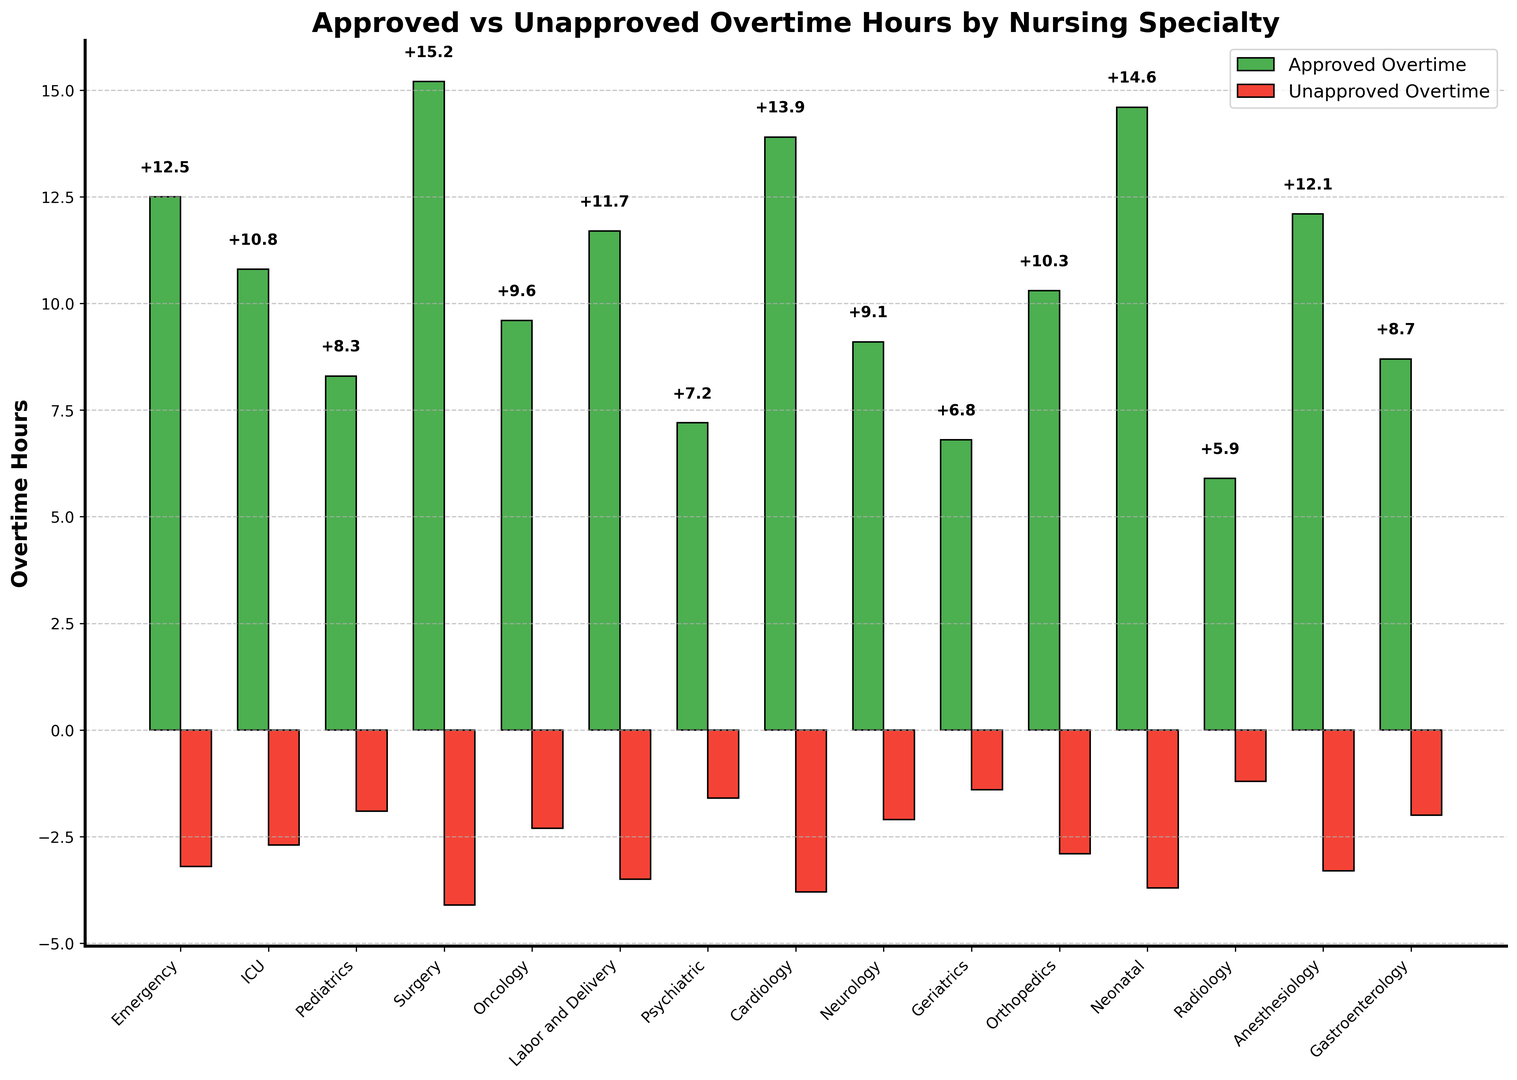Which nursing specialty has the highest approved overtime? The bar labeled "Surgery" reaches the highest point among the green bars, indicating it has the maximum approved overtime hours.
Answer: Surgery What is the difference between approved and unapproved overtime hours for Cardiology? Cardiology has 13.9 approved overtime hours and -3.8 unapproved overtime hours. The difference is 13.9 - (-3.8) = 17.7.
Answer: 17.7 Which specialty has the smallest amount of total overtime, whether approved or unapproved? Radiology has 5.9 approved overtime hours and -1.2 unapproved overtime hours. The sum is 5.9 + (-1.2) = 4.7, which is the smallest total value among all specialties.
Answer: Radiology How many specialties have unapproved overtime more negative than -3? By visually inspecting the bars on the right (red bars): Emergency, Surgery, Labor and Delivery, Cardiology, Neonatal, and Anesthesiology all have unapproved overtime values more negative than -3. This sums up to 6 specialties.
Answer: 6 Which specialties have more than 12 approved overtime hours? The green bars indicating approved overtime hours above 12 are seen in Emergency, Surgery, Cardiology, Neonatal, and Anesthesiology.
Answer: Emergency, Surgery, Cardiology, Neonatal, Anesthesiology What is the average amount of approved overtime for the three specialties with the most unapproved overtime? The specialties with the most unapproved overtime (most negative) are Surgery (-4.1), Neonatal (-3.7), and Cardiology (-3.8). Their approved overtime values are 15.2, 14.6, and 13.9. The sum of these values is 15.2 + 14.6 + 13.9 = 43.7. Dividing by 3, the average is 43.7 / 3 = 14.57.
Answer: 14.57 What is the total unapproved overtime for the specialties in critical care (Emergency, ICU)? Emergency has -3.2 unapproved overtime hours and ICU has -2.7 unapproved overtime hours. The total is -3.2 + (-2.7) = -5.9.
Answer: -5.9 Which specialty has the least approved overtime? The bar for Radiology in the green section is the shortest, indicating it has the least approved overtime.
Answer: Radiology What is the overall sum of approved overtime hours across all specialties? Summing up all the approved overtime values: 12.5 + 10.8 + 8.3 + 15.2 + 9.6 + 11.7 + 7.2 + 13.9 + 9.1 + 6.8 + 10.3 + 14.6 + 5.9 + 12.1 + 8.7 = 156.5.
Answer: 156.5 How does the approved overtime in Oncology compare to Pediatrics? Oncology has 9.6 approved overtime hours, whereas Pediatrics has 8.3. Since 9.6 is more than 8.3, Oncology has more approved overtime than Pediatrics.
Answer: Oncology has more 